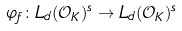<formula> <loc_0><loc_0><loc_500><loc_500>\varphi _ { f } \colon L _ { d } ( \mathcal { O } _ { K } ) ^ { s } \rightarrow L _ { d } ( \mathcal { O } _ { K } ) ^ { s }</formula> 